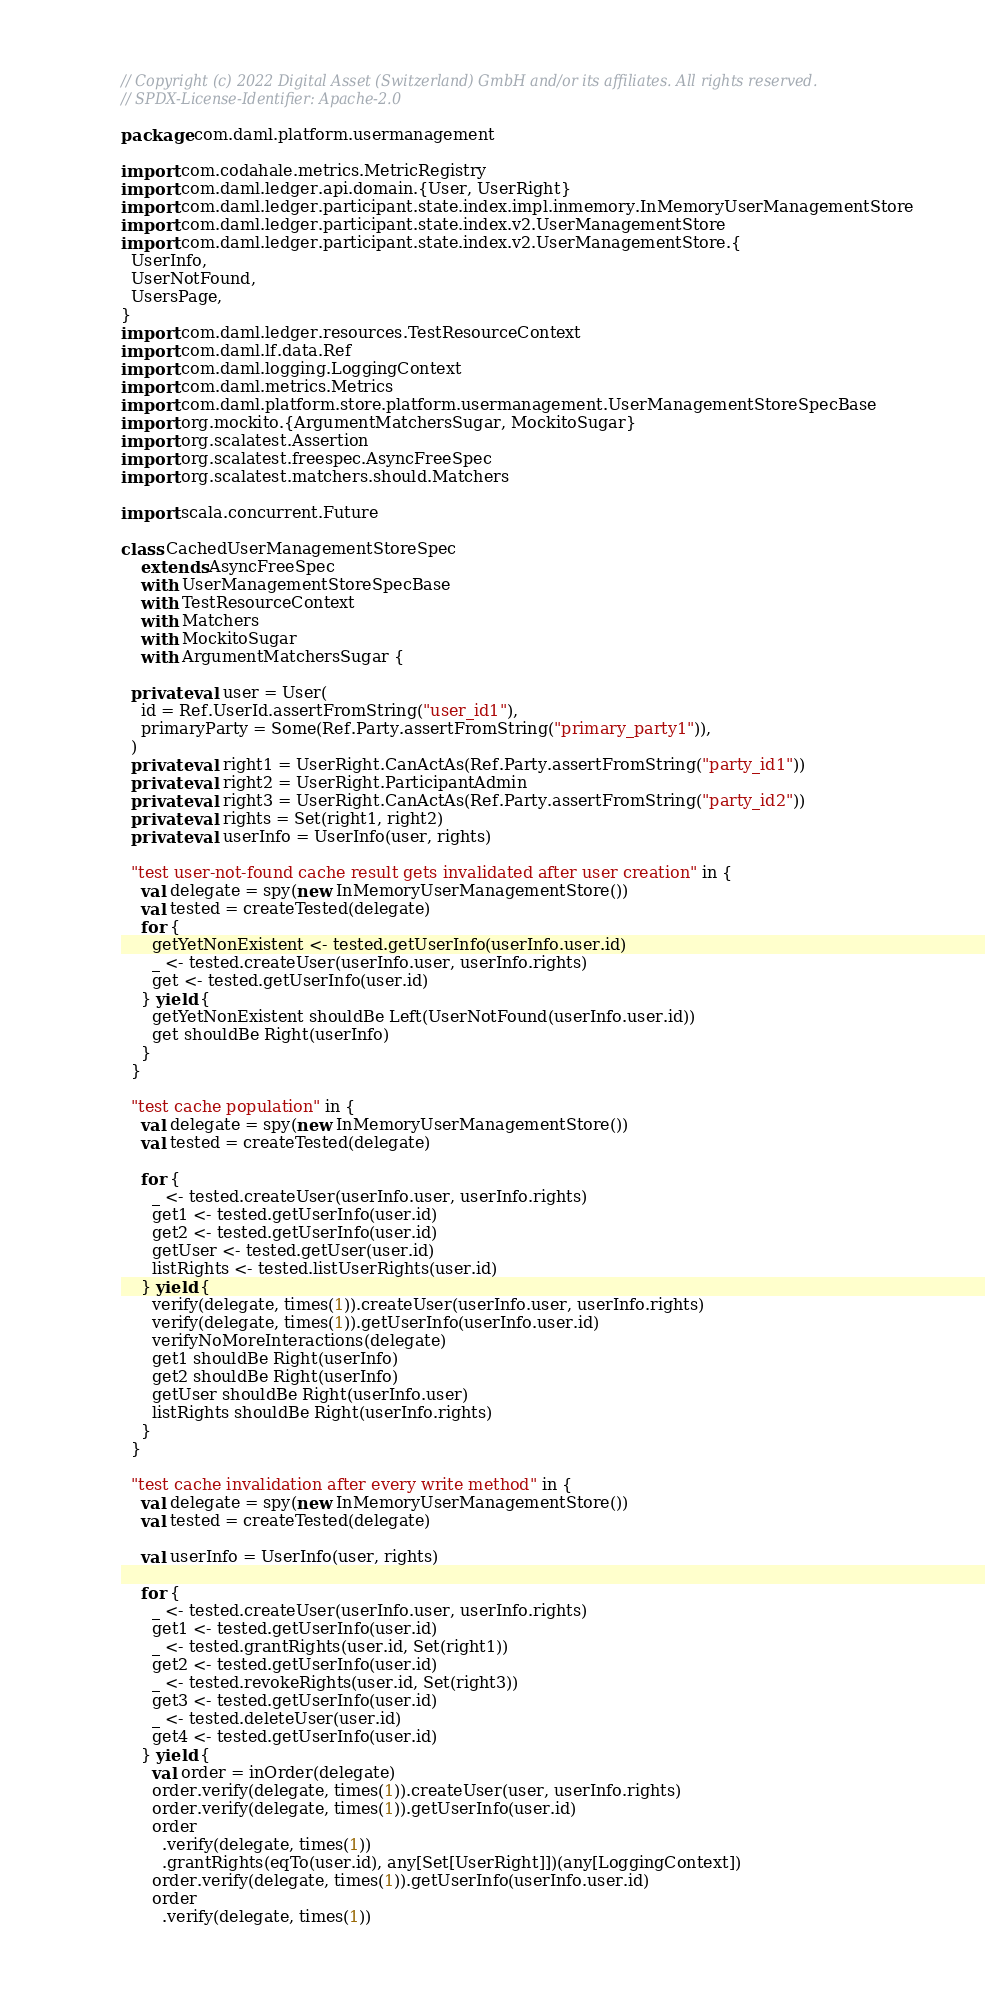Convert code to text. <code><loc_0><loc_0><loc_500><loc_500><_Scala_>// Copyright (c) 2022 Digital Asset (Switzerland) GmbH and/or its affiliates. All rights reserved.
// SPDX-License-Identifier: Apache-2.0

package com.daml.platform.usermanagement

import com.codahale.metrics.MetricRegistry
import com.daml.ledger.api.domain.{User, UserRight}
import com.daml.ledger.participant.state.index.impl.inmemory.InMemoryUserManagementStore
import com.daml.ledger.participant.state.index.v2.UserManagementStore
import com.daml.ledger.participant.state.index.v2.UserManagementStore.{
  UserInfo,
  UserNotFound,
  UsersPage,
}
import com.daml.ledger.resources.TestResourceContext
import com.daml.lf.data.Ref
import com.daml.logging.LoggingContext
import com.daml.metrics.Metrics
import com.daml.platform.store.platform.usermanagement.UserManagementStoreSpecBase
import org.mockito.{ArgumentMatchersSugar, MockitoSugar}
import org.scalatest.Assertion
import org.scalatest.freespec.AsyncFreeSpec
import org.scalatest.matchers.should.Matchers

import scala.concurrent.Future

class CachedUserManagementStoreSpec
    extends AsyncFreeSpec
    with UserManagementStoreSpecBase
    with TestResourceContext
    with Matchers
    with MockitoSugar
    with ArgumentMatchersSugar {

  private val user = User(
    id = Ref.UserId.assertFromString("user_id1"),
    primaryParty = Some(Ref.Party.assertFromString("primary_party1")),
  )
  private val right1 = UserRight.CanActAs(Ref.Party.assertFromString("party_id1"))
  private val right2 = UserRight.ParticipantAdmin
  private val right3 = UserRight.CanActAs(Ref.Party.assertFromString("party_id2"))
  private val rights = Set(right1, right2)
  private val userInfo = UserInfo(user, rights)

  "test user-not-found cache result gets invalidated after user creation" in {
    val delegate = spy(new InMemoryUserManagementStore())
    val tested = createTested(delegate)
    for {
      getYetNonExistent <- tested.getUserInfo(userInfo.user.id)
      _ <- tested.createUser(userInfo.user, userInfo.rights)
      get <- tested.getUserInfo(user.id)
    } yield {
      getYetNonExistent shouldBe Left(UserNotFound(userInfo.user.id))
      get shouldBe Right(userInfo)
    }
  }

  "test cache population" in {
    val delegate = spy(new InMemoryUserManagementStore())
    val tested = createTested(delegate)

    for {
      _ <- tested.createUser(userInfo.user, userInfo.rights)
      get1 <- tested.getUserInfo(user.id)
      get2 <- tested.getUserInfo(user.id)
      getUser <- tested.getUser(user.id)
      listRights <- tested.listUserRights(user.id)
    } yield {
      verify(delegate, times(1)).createUser(userInfo.user, userInfo.rights)
      verify(delegate, times(1)).getUserInfo(userInfo.user.id)
      verifyNoMoreInteractions(delegate)
      get1 shouldBe Right(userInfo)
      get2 shouldBe Right(userInfo)
      getUser shouldBe Right(userInfo.user)
      listRights shouldBe Right(userInfo.rights)
    }
  }

  "test cache invalidation after every write method" in {
    val delegate = spy(new InMemoryUserManagementStore())
    val tested = createTested(delegate)

    val userInfo = UserInfo(user, rights)

    for {
      _ <- tested.createUser(userInfo.user, userInfo.rights)
      get1 <- tested.getUserInfo(user.id)
      _ <- tested.grantRights(user.id, Set(right1))
      get2 <- tested.getUserInfo(user.id)
      _ <- tested.revokeRights(user.id, Set(right3))
      get3 <- tested.getUserInfo(user.id)
      _ <- tested.deleteUser(user.id)
      get4 <- tested.getUserInfo(user.id)
    } yield {
      val order = inOrder(delegate)
      order.verify(delegate, times(1)).createUser(user, userInfo.rights)
      order.verify(delegate, times(1)).getUserInfo(user.id)
      order
        .verify(delegate, times(1))
        .grantRights(eqTo(user.id), any[Set[UserRight]])(any[LoggingContext])
      order.verify(delegate, times(1)).getUserInfo(userInfo.user.id)
      order
        .verify(delegate, times(1))</code> 